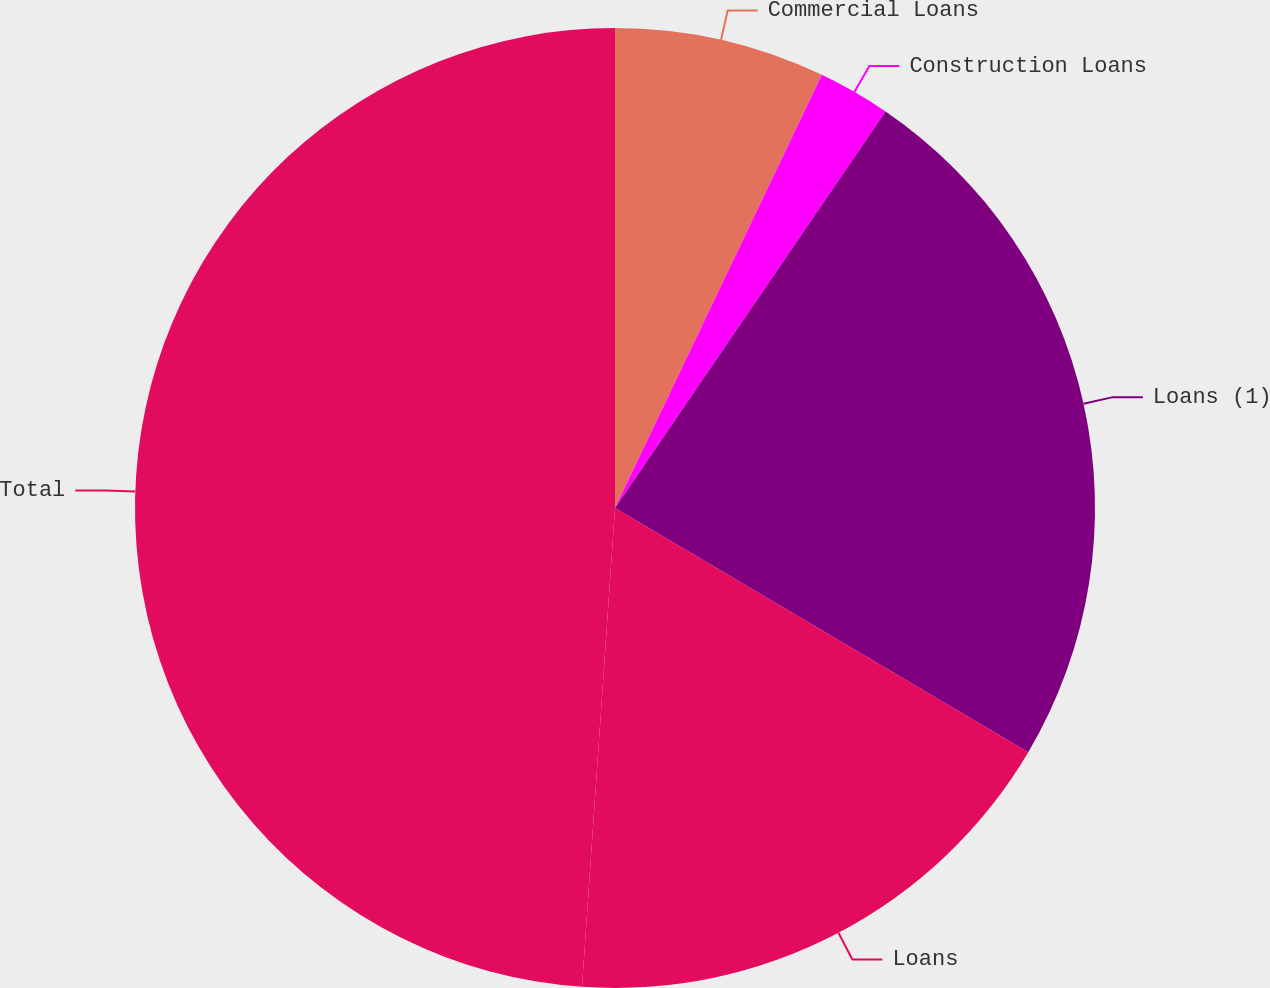Convert chart to OTSL. <chart><loc_0><loc_0><loc_500><loc_500><pie_chart><fcel>Commercial Loans<fcel>Construction Loans<fcel>Loans (1)<fcel>Loans<fcel>Total<nl><fcel>7.09%<fcel>2.44%<fcel>23.96%<fcel>17.6%<fcel>48.9%<nl></chart> 